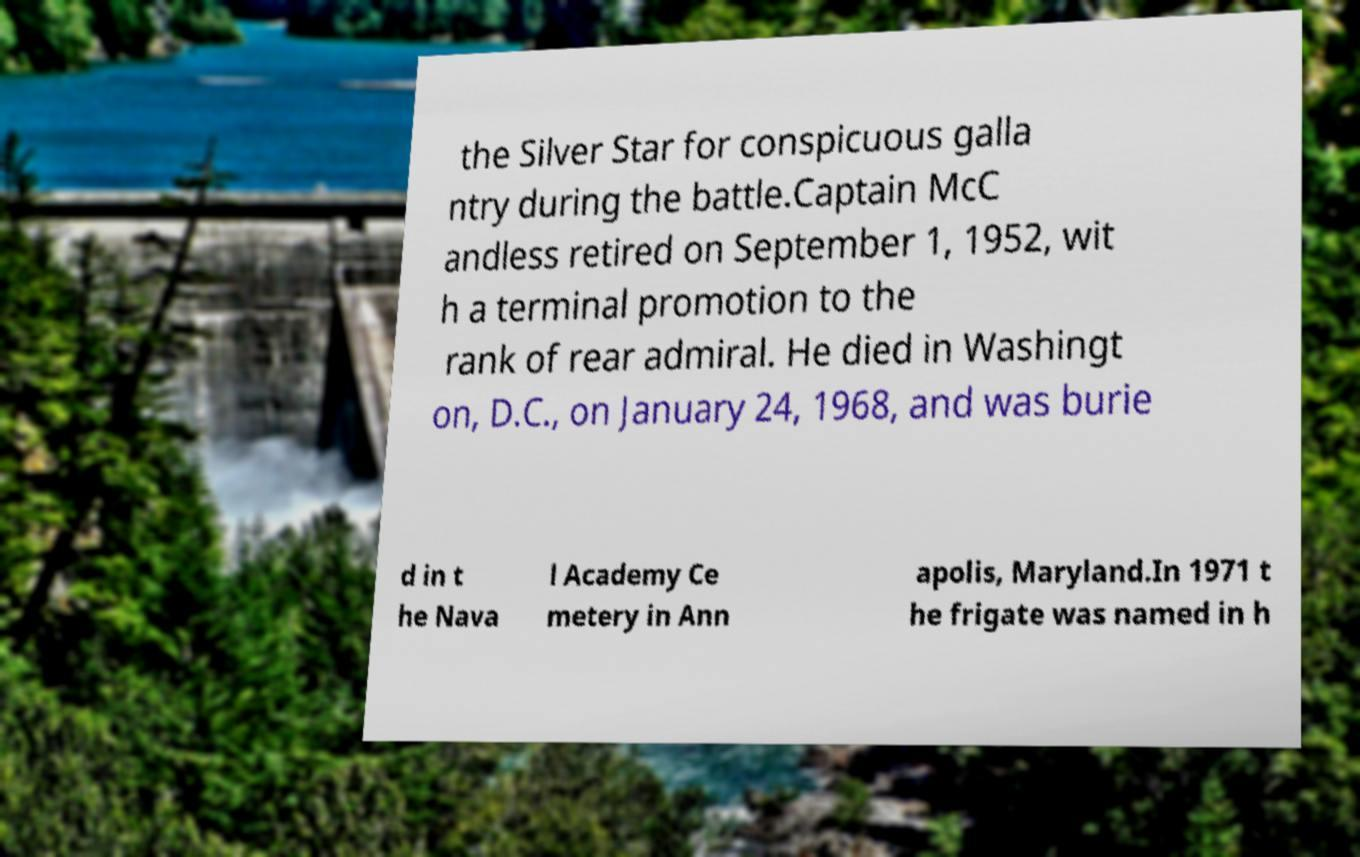Can you read and provide the text displayed in the image?This photo seems to have some interesting text. Can you extract and type it out for me? the Silver Star for conspicuous galla ntry during the battle.Captain McC andless retired on September 1, 1952, wit h a terminal promotion to the rank of rear admiral. He died in Washingt on, D.C., on January 24, 1968, and was burie d in t he Nava l Academy Ce metery in Ann apolis, Maryland.In 1971 t he frigate was named in h 